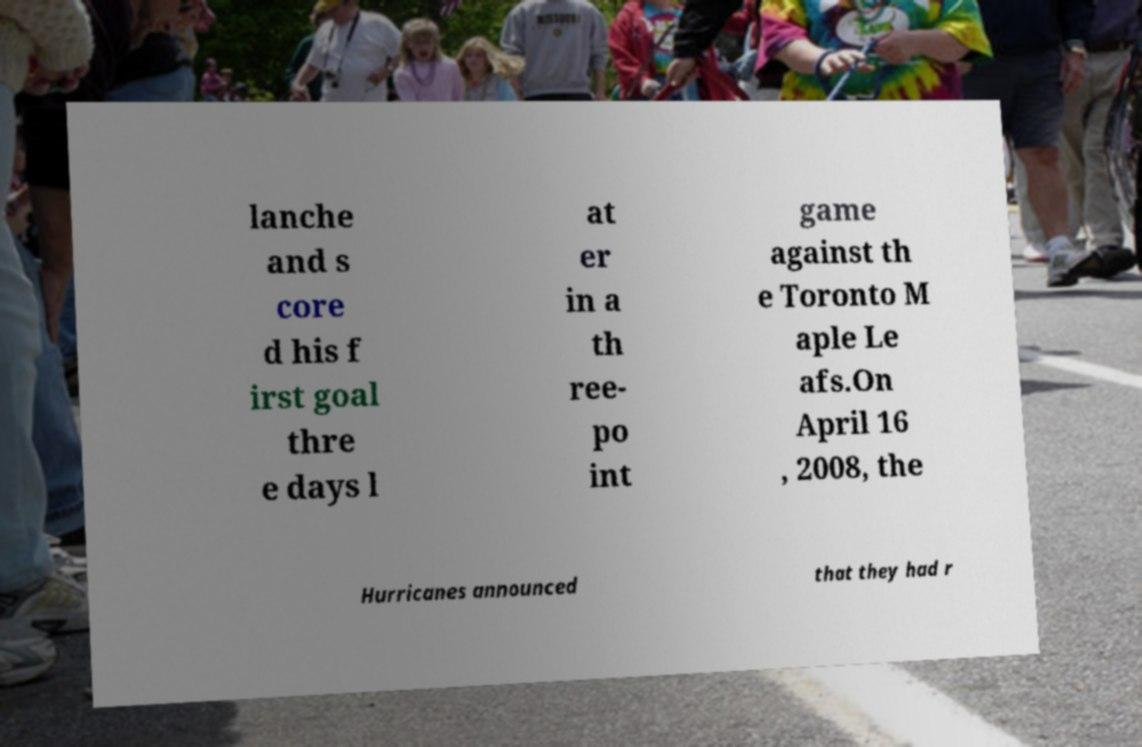For documentation purposes, I need the text within this image transcribed. Could you provide that? lanche and s core d his f irst goal thre e days l at er in a th ree- po int game against th e Toronto M aple Le afs.On April 16 , 2008, the Hurricanes announced that they had r 